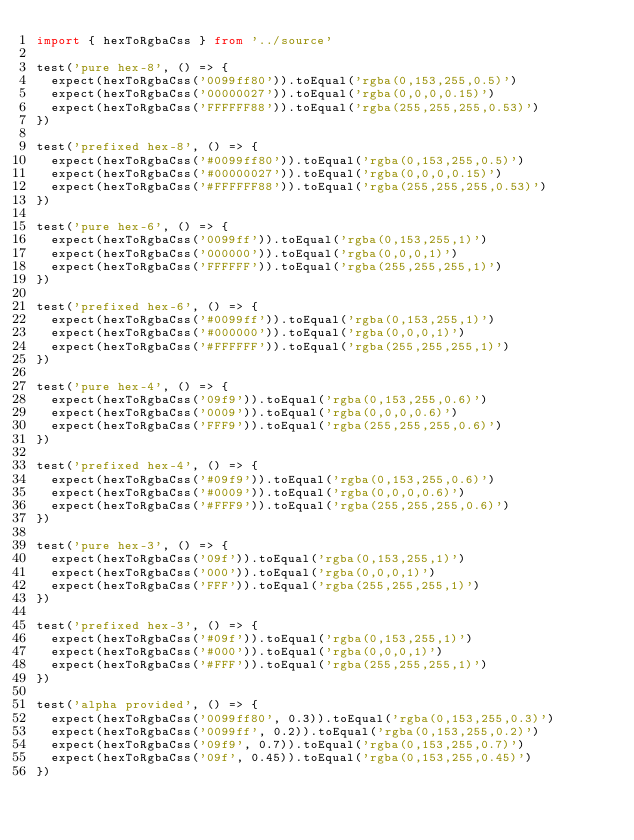<code> <loc_0><loc_0><loc_500><loc_500><_TypeScript_>import { hexToRgbaCss } from '../source'

test('pure hex-8', () => {
  expect(hexToRgbaCss('0099ff80')).toEqual('rgba(0,153,255,0.5)')
  expect(hexToRgbaCss('00000027')).toEqual('rgba(0,0,0,0.15)')
  expect(hexToRgbaCss('FFFFFF88')).toEqual('rgba(255,255,255,0.53)')
})

test('prefixed hex-8', () => {
  expect(hexToRgbaCss('#0099ff80')).toEqual('rgba(0,153,255,0.5)')
  expect(hexToRgbaCss('#00000027')).toEqual('rgba(0,0,0,0.15)')
  expect(hexToRgbaCss('#FFFFFF88')).toEqual('rgba(255,255,255,0.53)')
})

test('pure hex-6', () => {
  expect(hexToRgbaCss('0099ff')).toEqual('rgba(0,153,255,1)')
  expect(hexToRgbaCss('000000')).toEqual('rgba(0,0,0,1)')
  expect(hexToRgbaCss('FFFFFF')).toEqual('rgba(255,255,255,1)')
})

test('prefixed hex-6', () => {
  expect(hexToRgbaCss('#0099ff')).toEqual('rgba(0,153,255,1)')
  expect(hexToRgbaCss('#000000')).toEqual('rgba(0,0,0,1)')
  expect(hexToRgbaCss('#FFFFFF')).toEqual('rgba(255,255,255,1)')
})

test('pure hex-4', () => {
  expect(hexToRgbaCss('09f9')).toEqual('rgba(0,153,255,0.6)')
  expect(hexToRgbaCss('0009')).toEqual('rgba(0,0,0,0.6)')
  expect(hexToRgbaCss('FFF9')).toEqual('rgba(255,255,255,0.6)')
})

test('prefixed hex-4', () => {
  expect(hexToRgbaCss('#09f9')).toEqual('rgba(0,153,255,0.6)')
  expect(hexToRgbaCss('#0009')).toEqual('rgba(0,0,0,0.6)')
  expect(hexToRgbaCss('#FFF9')).toEqual('rgba(255,255,255,0.6)')
})

test('pure hex-3', () => {
  expect(hexToRgbaCss('09f')).toEqual('rgba(0,153,255,1)')
  expect(hexToRgbaCss('000')).toEqual('rgba(0,0,0,1)')
  expect(hexToRgbaCss('FFF')).toEqual('rgba(255,255,255,1)')
})

test('prefixed hex-3', () => {
  expect(hexToRgbaCss('#09f')).toEqual('rgba(0,153,255,1)')
  expect(hexToRgbaCss('#000')).toEqual('rgba(0,0,0,1)')
  expect(hexToRgbaCss('#FFF')).toEqual('rgba(255,255,255,1)')
})

test('alpha provided', () => {
  expect(hexToRgbaCss('0099ff80', 0.3)).toEqual('rgba(0,153,255,0.3)')
  expect(hexToRgbaCss('0099ff', 0.2)).toEqual('rgba(0,153,255,0.2)')
  expect(hexToRgbaCss('09f9', 0.7)).toEqual('rgba(0,153,255,0.7)')
  expect(hexToRgbaCss('09f', 0.45)).toEqual('rgba(0,153,255,0.45)')
})
</code> 